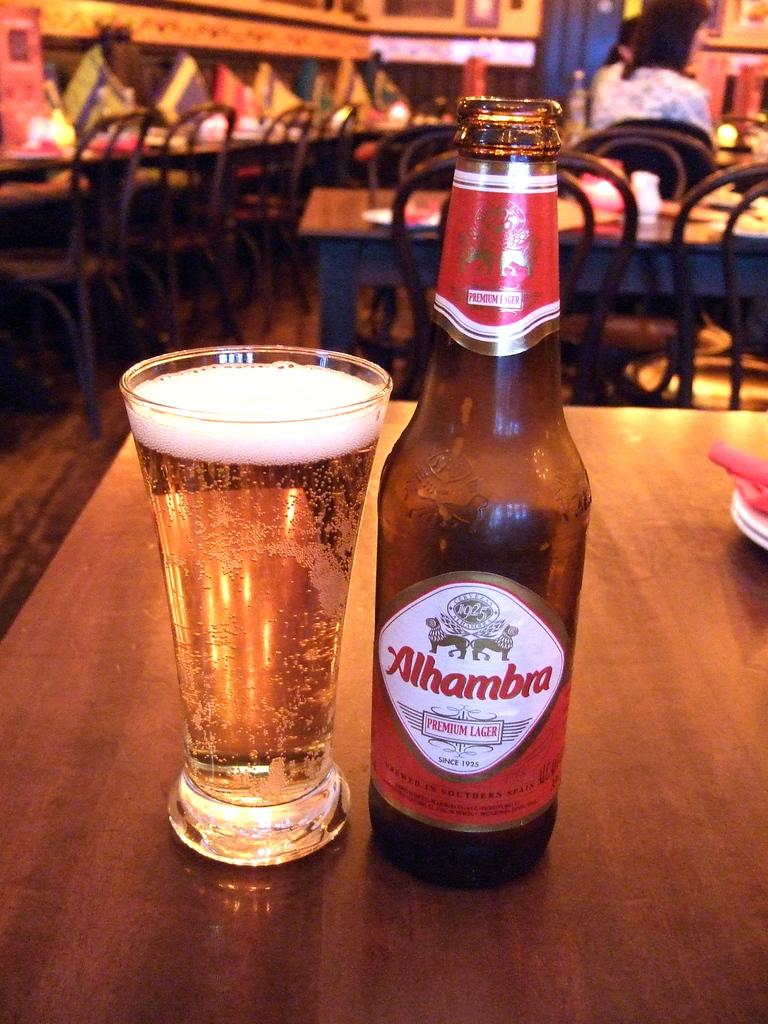What is the name of this beer?
Your answer should be very brief. Alhambra. 